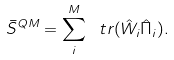<formula> <loc_0><loc_0><loc_500><loc_500>\bar { S } ^ { Q M } = \sum _ { i } ^ { M } \ t r { ( \hat { W } _ { i } \hat { \Pi } _ { i } ) } .</formula> 